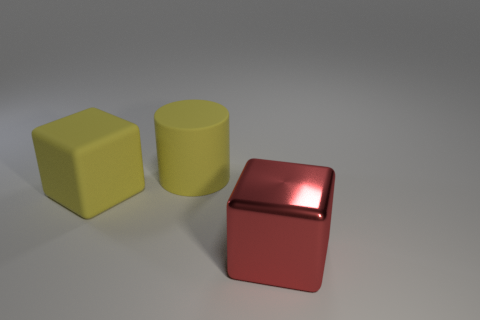Is the cylinder the same color as the big rubber block?
Your answer should be compact. Yes. Is the red block the same size as the yellow matte cube?
Offer a terse response. Yes. Does the large matte thing that is behind the matte cube have the same color as the big matte cube?
Your response must be concise. Yes. There is a yellow rubber block; what number of yellow objects are behind it?
Provide a short and direct response. 1. Are there more large metallic objects than small gray rubber cylinders?
Make the answer very short. Yes. There is a thing that is in front of the large yellow rubber cylinder and right of the yellow cube; what shape is it?
Your answer should be compact. Cube. Are any small blue metallic spheres visible?
Offer a terse response. No. There is a big yellow thing that is the same shape as the red thing; what is its material?
Offer a very short reply. Rubber. What is the shape of the big yellow object that is in front of the yellow object that is on the right side of the big matte thing that is on the left side of the yellow rubber cylinder?
Ensure brevity in your answer.  Cube. What material is the cube that is the same color as the rubber cylinder?
Offer a terse response. Rubber. 